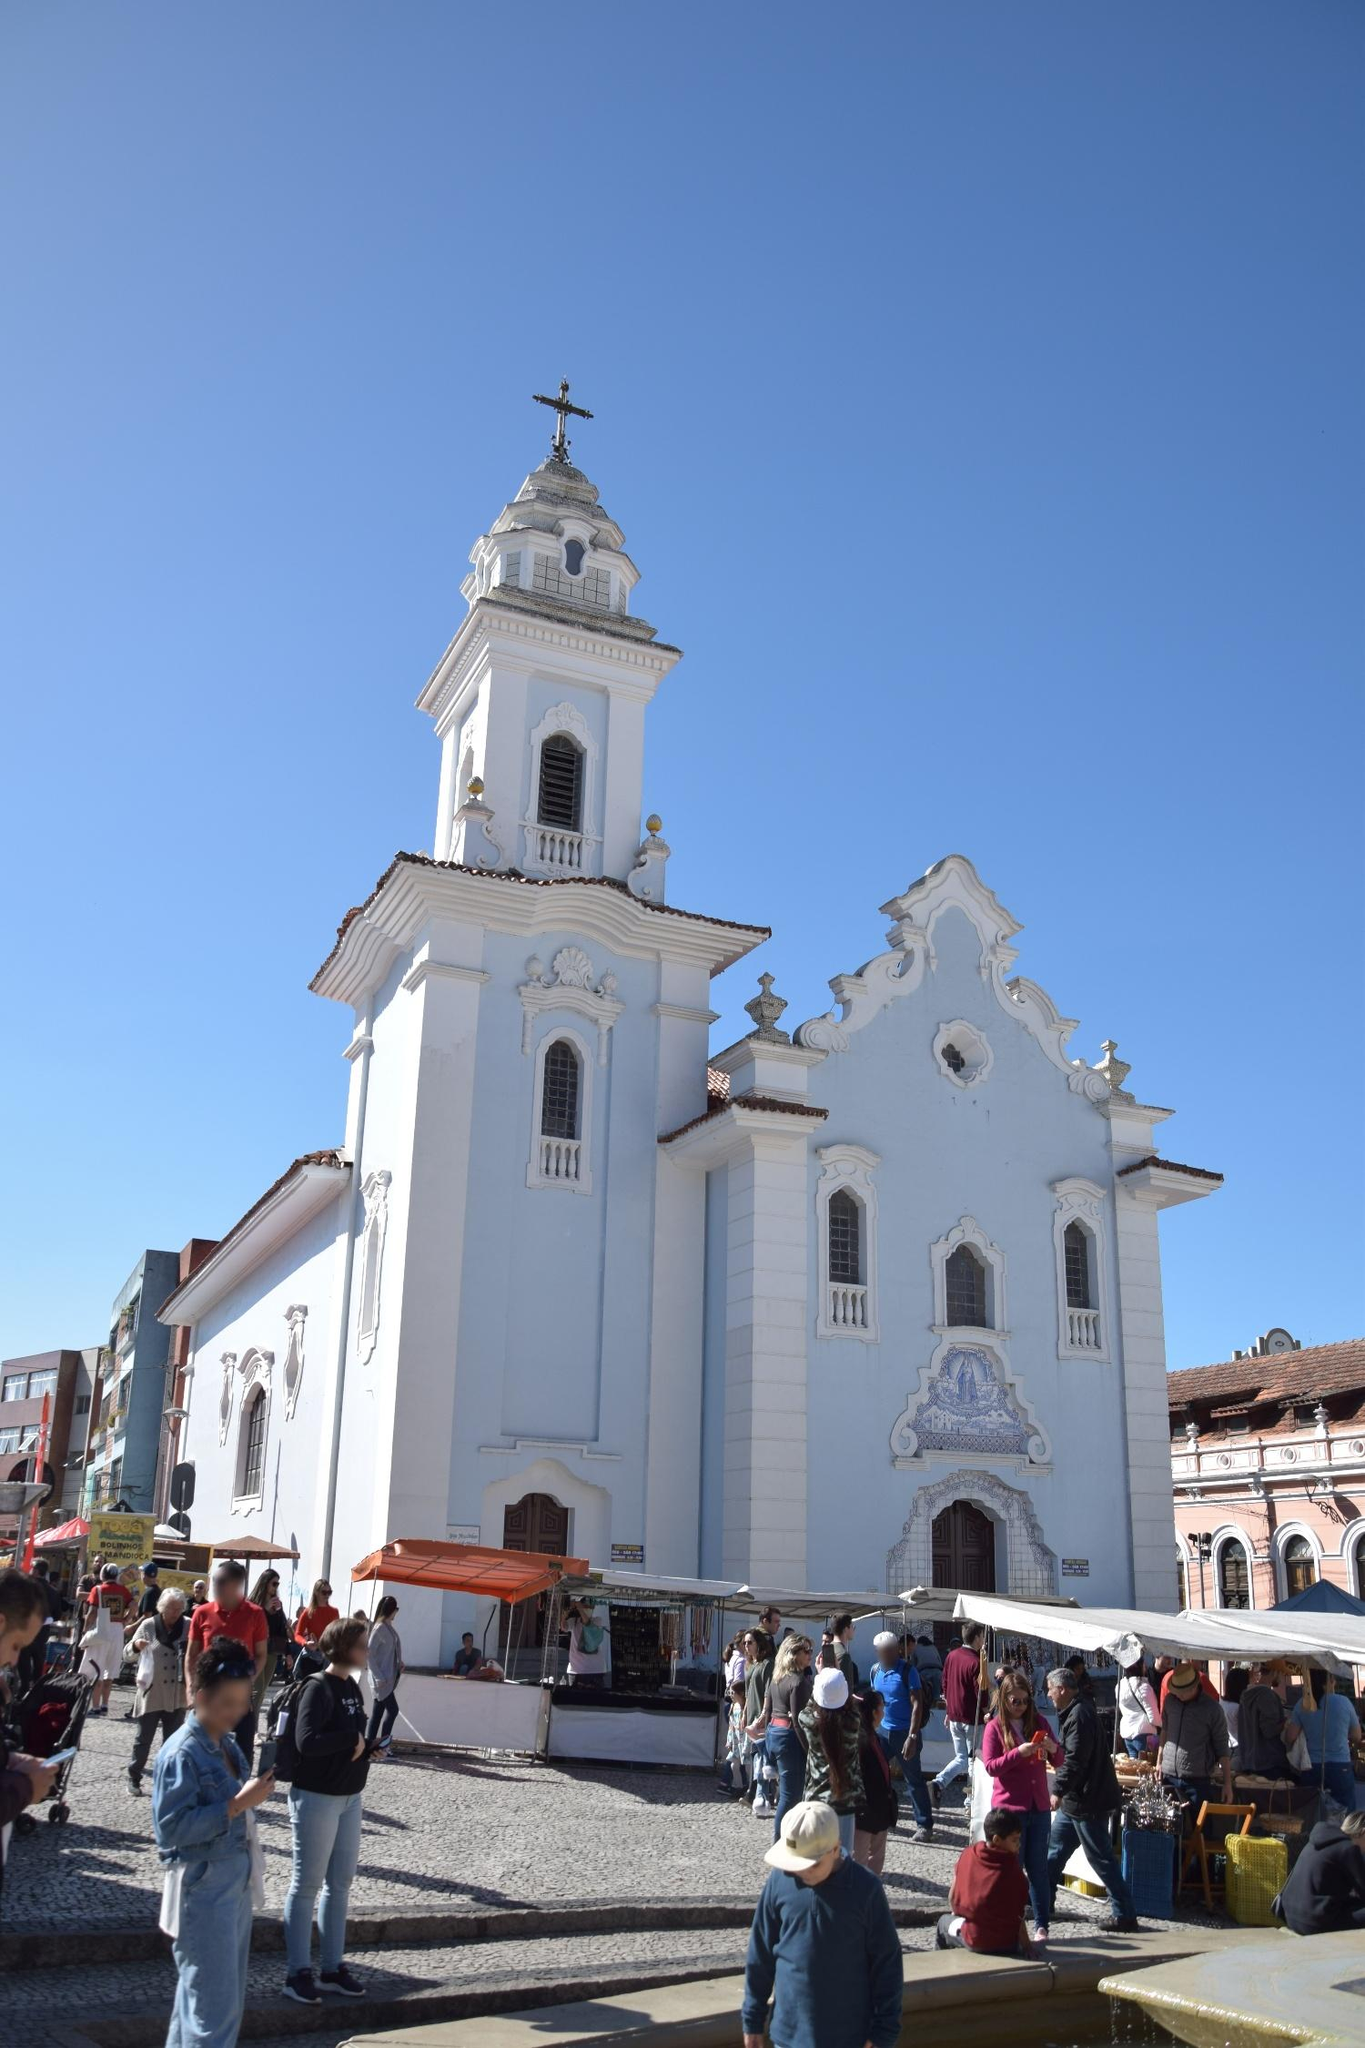I wonder about the materials used in building the church. What can you tell me about that? The construction of the Igreja de Nossa Senhora do Rosário dos Pretos involved the use of traditional building materials typical of the time period and region. The primary material is limestone, giving the church its distinct white facade. The ornate stucco work on the facade, which features intricately detailed religious motifs and architectural elements, was likely crafted with a combination of lime plaster and sand. The roof tiles are made from terracotta, a common roofing material that was both durable and aesthetically pleasing. Inside the church, you might find beautiful wooden carvings, likely made from native woods, alongside stone altars and marble flooring. These materials not only contribute to the church's structural integrity but also reflect the craftsmanship and artistic dedication of its builders. Could you share an interesting legend or story related to this church? An interesting legend associated with the Igreja de Nossa Senhora do Rosário dos Pretos tells of the church's miraculous origins. It is said that the church’s site was once a barren piece of land, often thought to be cursed due to its inability to sustain any construction. According to the legend, a group of African slaves and freedmen decided to build a church dedicated to Our Lady of the Rosary on this very site, invoking her protection and blessings. Against all odds, the construction went smoothly, and the church rose magnificently. Stories of miraculous healings and answered prayers soon followed, further solidifying the site's sacred status. This legend not only highlights the faith and determination of the church’s builders but also adds an aura of divine intervention and sanctity to its history. 